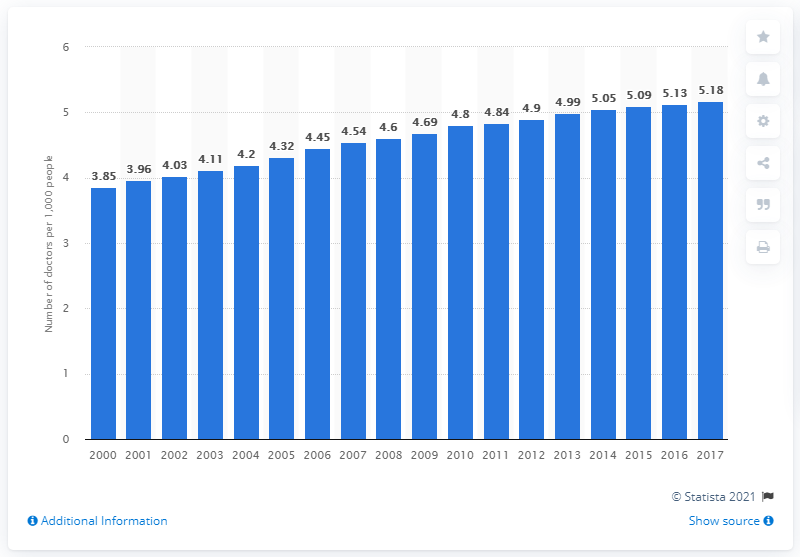Specify some key components in this picture. In 2017, there were approximately 5.18 doctors practicing in Austria. 